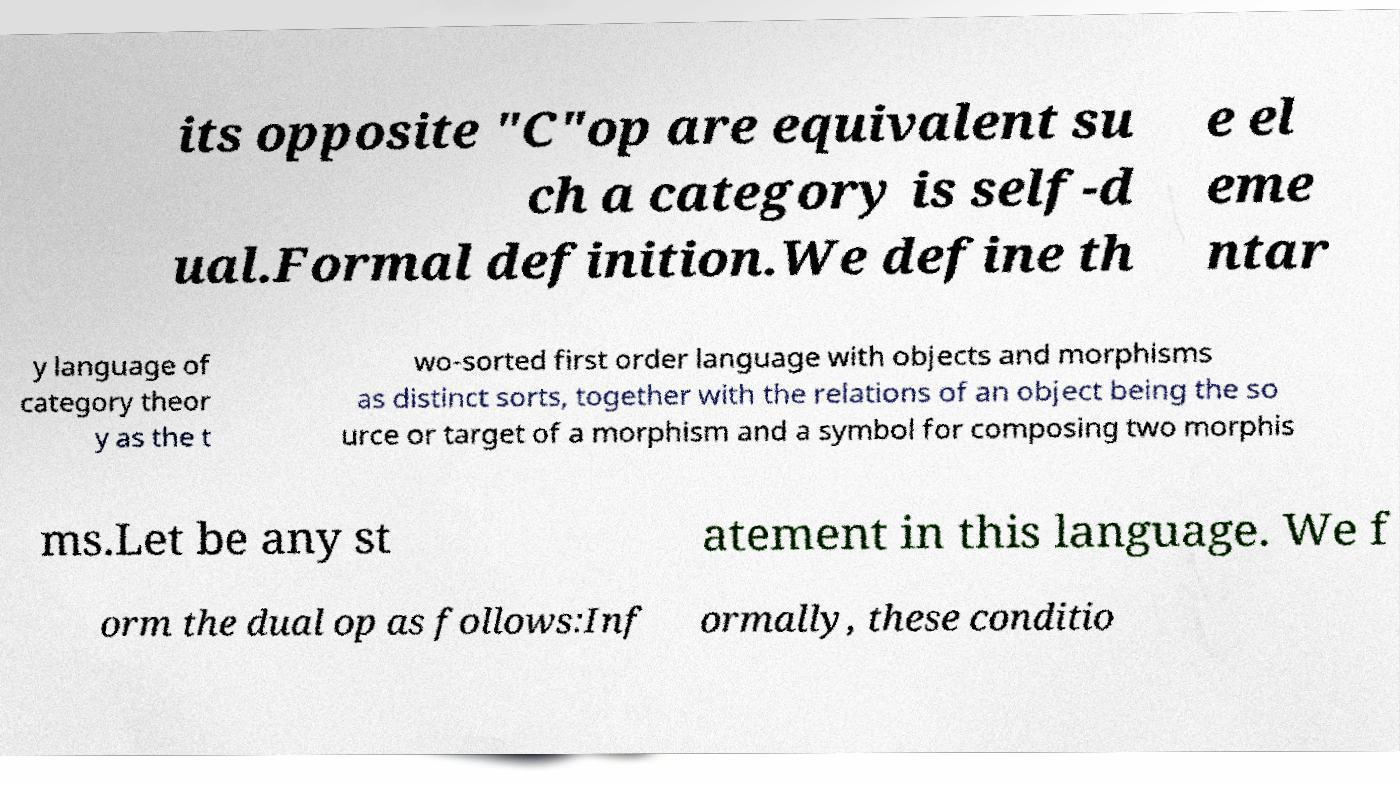There's text embedded in this image that I need extracted. Can you transcribe it verbatim? its opposite "C"op are equivalent su ch a category is self-d ual.Formal definition.We define th e el eme ntar y language of category theor y as the t wo-sorted first order language with objects and morphisms as distinct sorts, together with the relations of an object being the so urce or target of a morphism and a symbol for composing two morphis ms.Let be any st atement in this language. We f orm the dual op as follows:Inf ormally, these conditio 